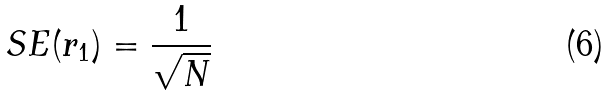Convert formula to latex. <formula><loc_0><loc_0><loc_500><loc_500>S E ( r _ { 1 } ) = \frac { 1 } { \sqrt { N } }</formula> 